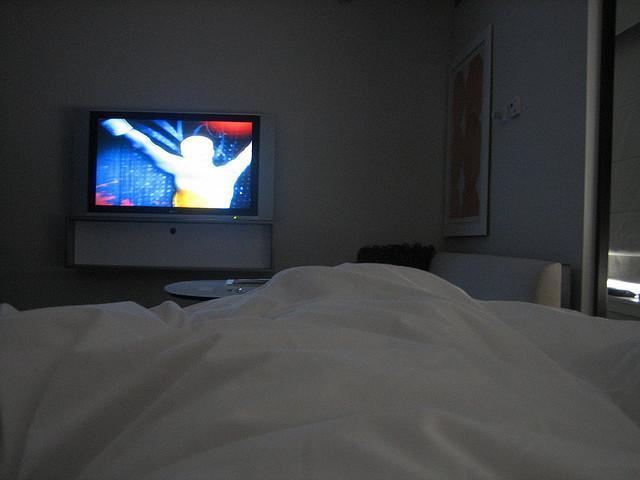How many people in the image have on backpacks?
Give a very brief answer. 0. 